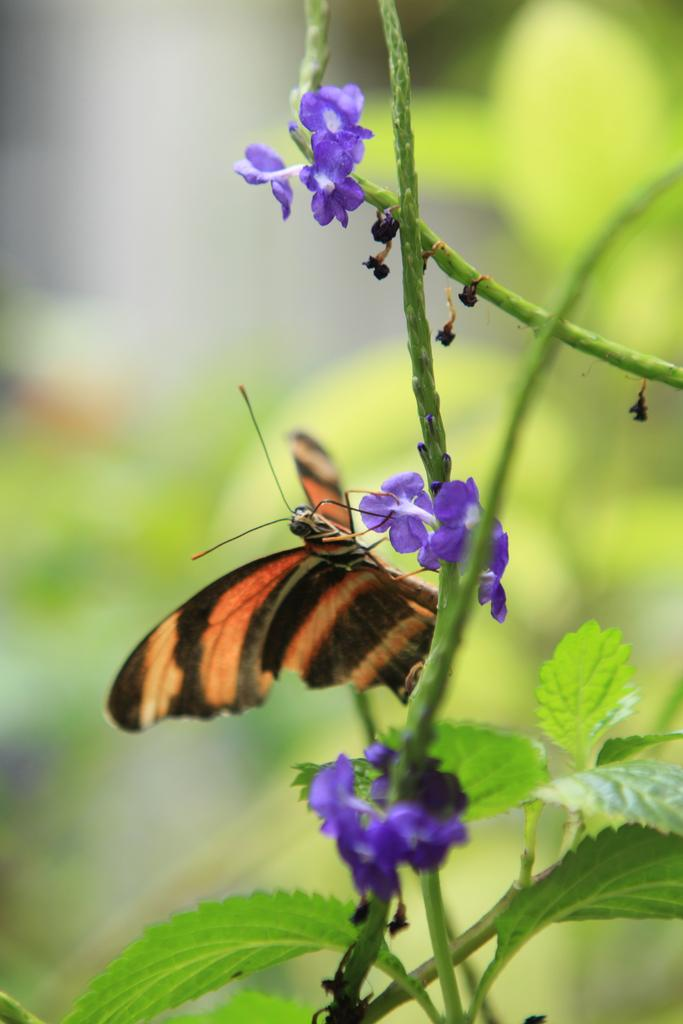What type of plant is visible in the image? There is a plant with flowers in the image. Are there any animals or insects on the plant? Yes, there is a butterfly on the plant. Can you describe the background of the image? The background of the image is blurred. What type of truck can be seen driving through the flowers in the image? There is no truck present in the image; it features a plant with flowers and a butterfly. What show is the butterfly attending in the image? Butterflies do not attend shows, and there is no indication of any event in the image. 